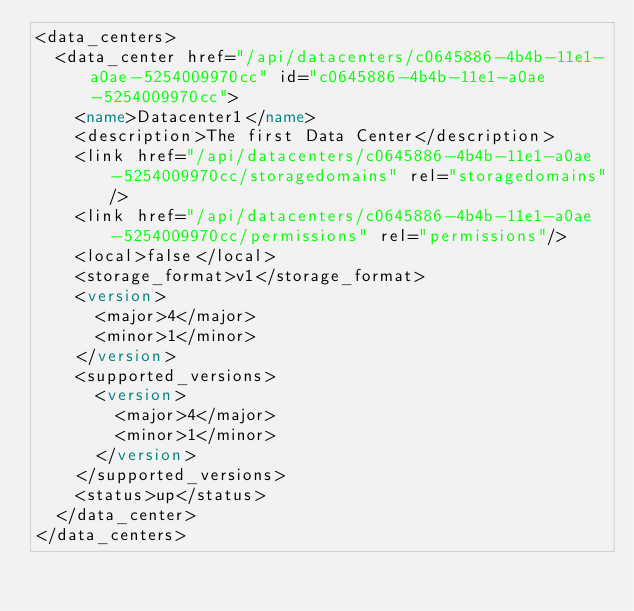Convert code to text. <code><loc_0><loc_0><loc_500><loc_500><_XML_><data_centers>
  <data_center href="/api/datacenters/c0645886-4b4b-11e1-a0ae-5254009970cc" id="c0645886-4b4b-11e1-a0ae-5254009970cc">
    <name>Datacenter1</name>
    <description>The first Data Center</description>
    <link href="/api/datacenters/c0645886-4b4b-11e1-a0ae-5254009970cc/storagedomains" rel="storagedomains"/>
    <link href="/api/datacenters/c0645886-4b4b-11e1-a0ae-5254009970cc/permissions" rel="permissions"/>
    <local>false</local>
    <storage_format>v1</storage_format>
    <version>
      <major>4</major>
      <minor>1</minor>
    </version>
    <supported_versions>
      <version>
        <major>4</major>
        <minor>1</minor>
      </version>
    </supported_versions>
    <status>up</status>
  </data_center>
</data_centers>
</code> 